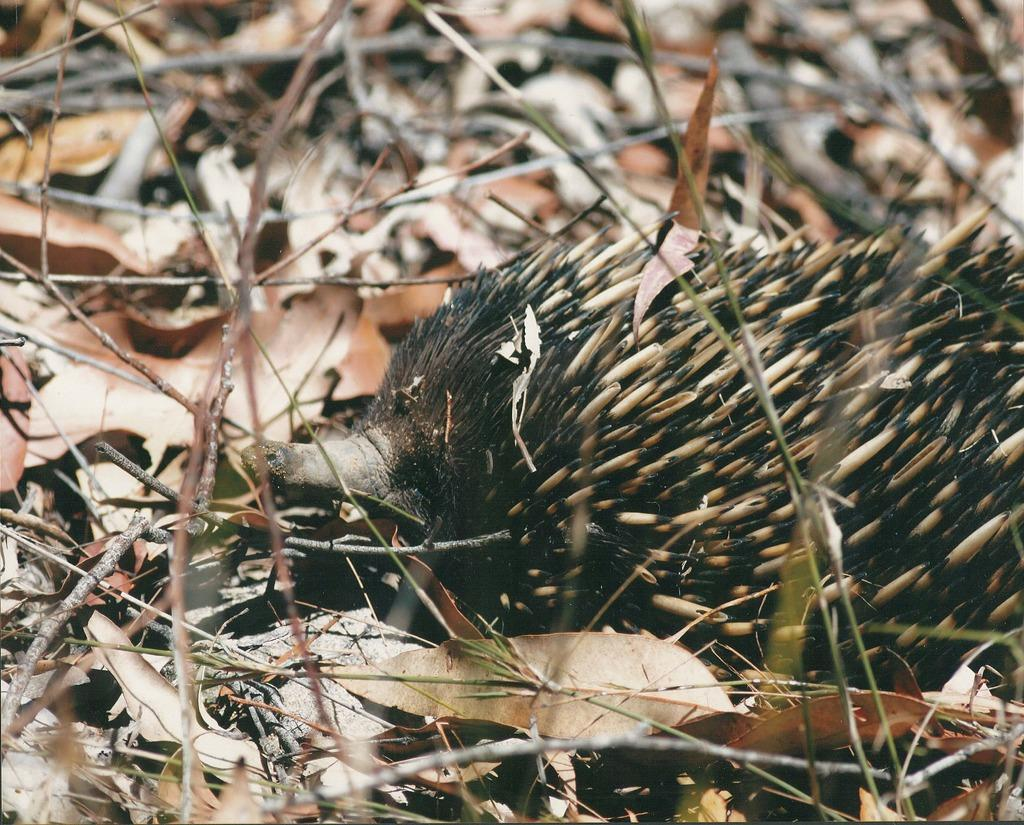What type of natural elements can be seen in the image? There are dry leaves and twigs in the image. Can you describe any other objects present in the image? Yes, there are other objects in the image. What type of shirt is the man wearing in the image? There is no man present in the image, so it is not possible to determine what type of shirt he might be wearing. 